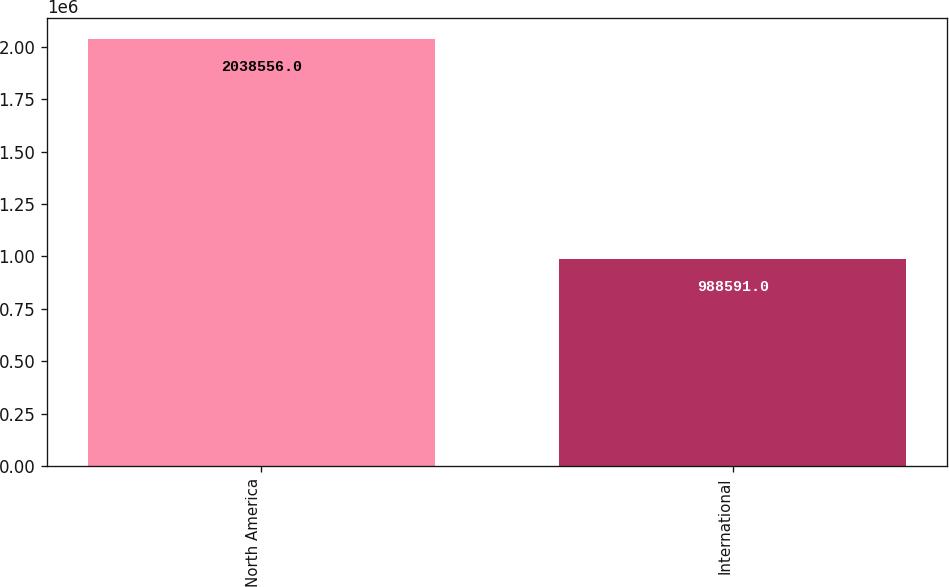<chart> <loc_0><loc_0><loc_500><loc_500><bar_chart><fcel>North America<fcel>International<nl><fcel>2.03856e+06<fcel>988591<nl></chart> 